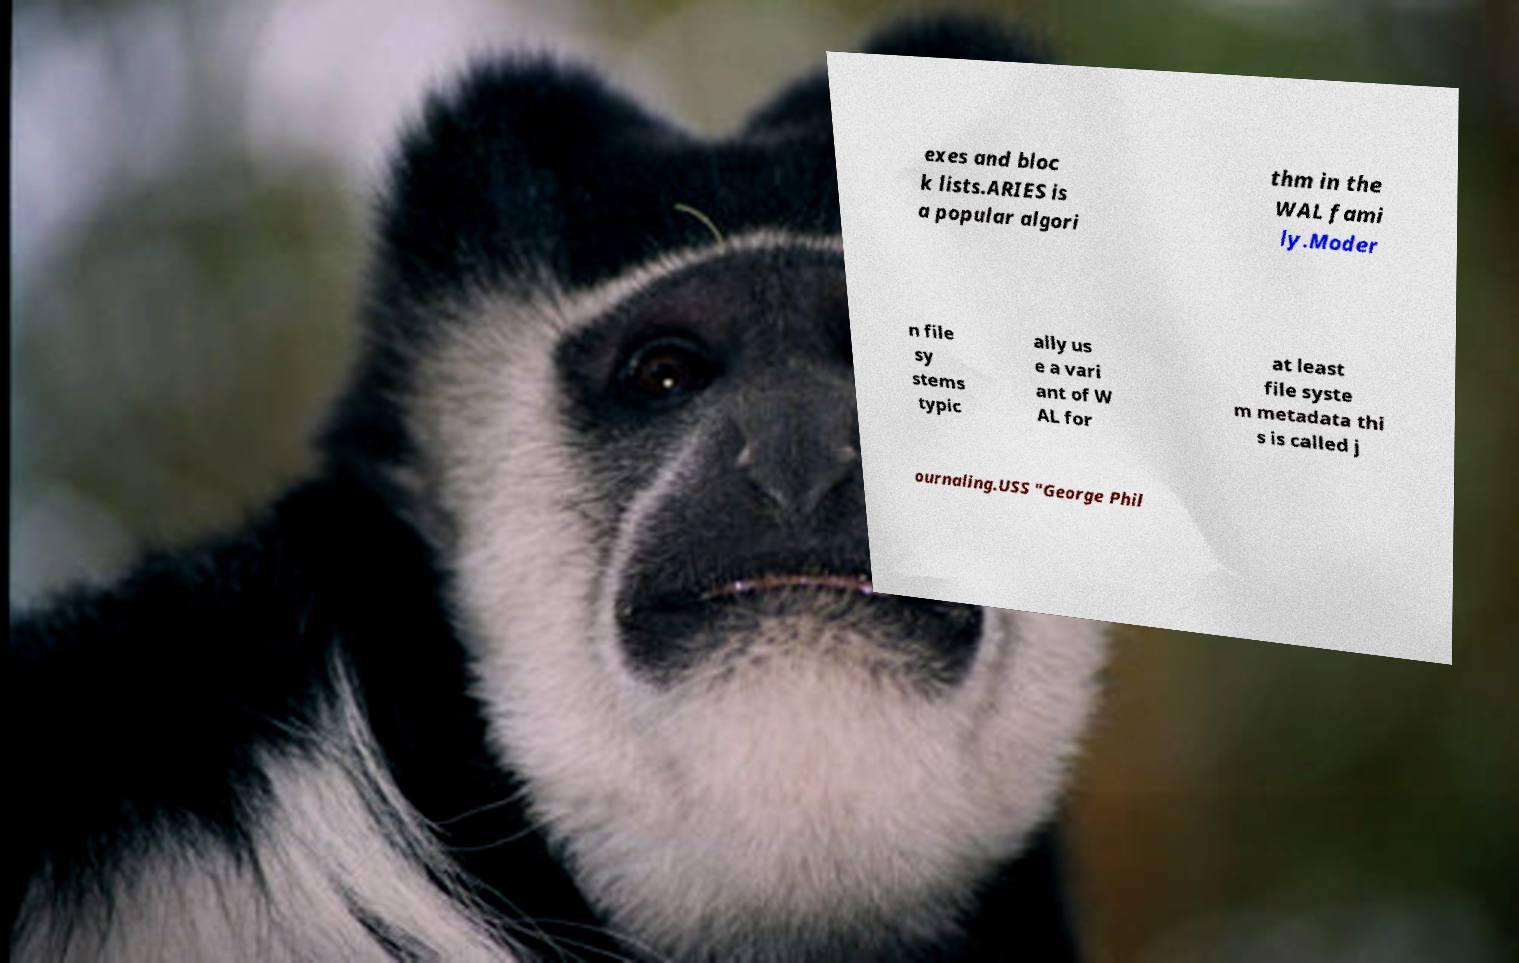Could you assist in decoding the text presented in this image and type it out clearly? exes and bloc k lists.ARIES is a popular algori thm in the WAL fami ly.Moder n file sy stems typic ally us e a vari ant of W AL for at least file syste m metadata thi s is called j ournaling.USS "George Phil 